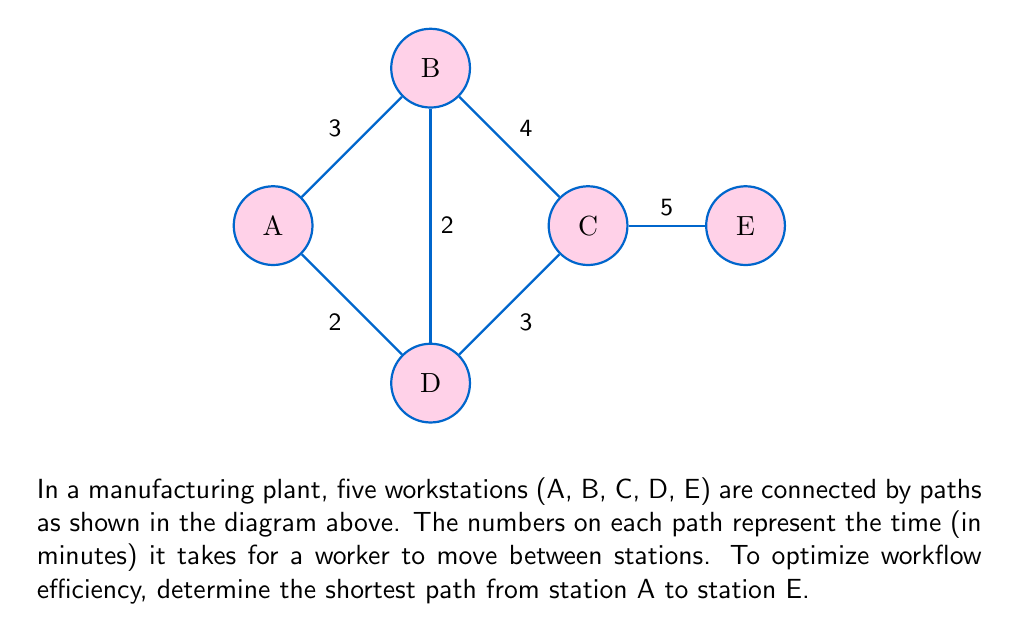Show me your answer to this math problem. To solve this problem, we can use Dijkstra's algorithm, which is an efficient method for finding the shortest path in a graph. Let's follow these steps:

1) Initialize:
   - Set distance to A as 0 and all other nodes as infinity.
   - Mark all nodes as unvisited.

2) For the current node (starting with A), consider all unvisited neighbors and calculate their tentative distances.
   - From A: B(3), D(2)

3) Mark the current node as visited and move to the unvisited node with the smallest tentative distance.
   - Mark A as visited, move to D (distance 2)

4) Repeat step 2 for the new current node:
   - From D: B(2+2=4), C(2+3=5)

5) Mark D as visited and move to B (smallest tentative distance of 3)

6) From B: C(3+4=7) - but we already have a shorter path to C via D

7) Mark B as visited and move to C (distance 5)

8) From C: E(5+5=10)

9) Mark C as visited and move to E (distance 10)

The shortest path is thus: A → D → C → E

Total distance: 2 + 3 + 5 = 10 minutes

This method ensures the most efficient workflow by minimizing travel time between workstations, which is crucial for optimizing worker performance and productivity in an industrial setting.
Answer: A → D → C → E, 10 minutes 